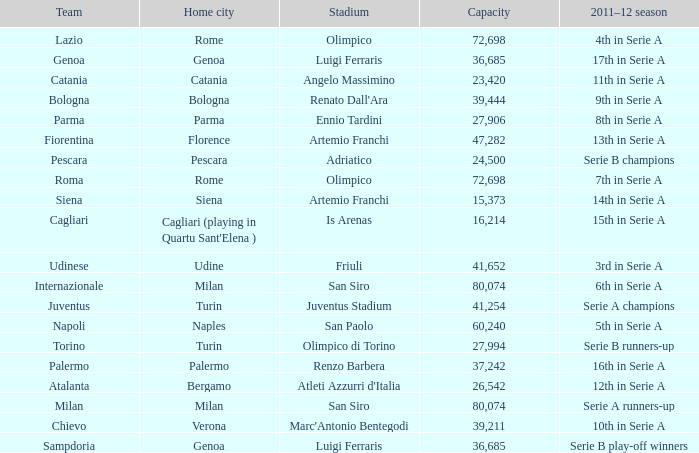What team had a capacity of over 26,542, a home city of milan, and finished the 2011-2012 season 6th in serie a? Internazionale. 